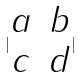<formula> <loc_0><loc_0><loc_500><loc_500>| \begin{matrix} a & b \\ c & d \end{matrix} |</formula> 